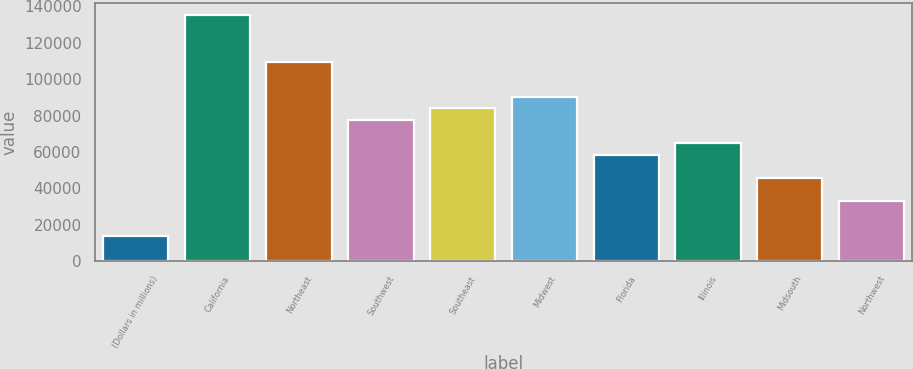Convert chart to OTSL. <chart><loc_0><loc_0><loc_500><loc_500><bar_chart><fcel>(Dollars in millions)<fcel>California<fcel>Northeast<fcel>Southwest<fcel>Southeast<fcel>Midwest<fcel>Florida<fcel>Illinois<fcel>Midsouth<fcel>Northwest<nl><fcel>13764<fcel>135222<fcel>109652<fcel>77689<fcel>84081.5<fcel>90474<fcel>58511.5<fcel>64904<fcel>45726.5<fcel>32941.5<nl></chart> 